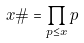Convert formula to latex. <formula><loc_0><loc_0><loc_500><loc_500>x \# = \prod _ { p \leq x } p</formula> 